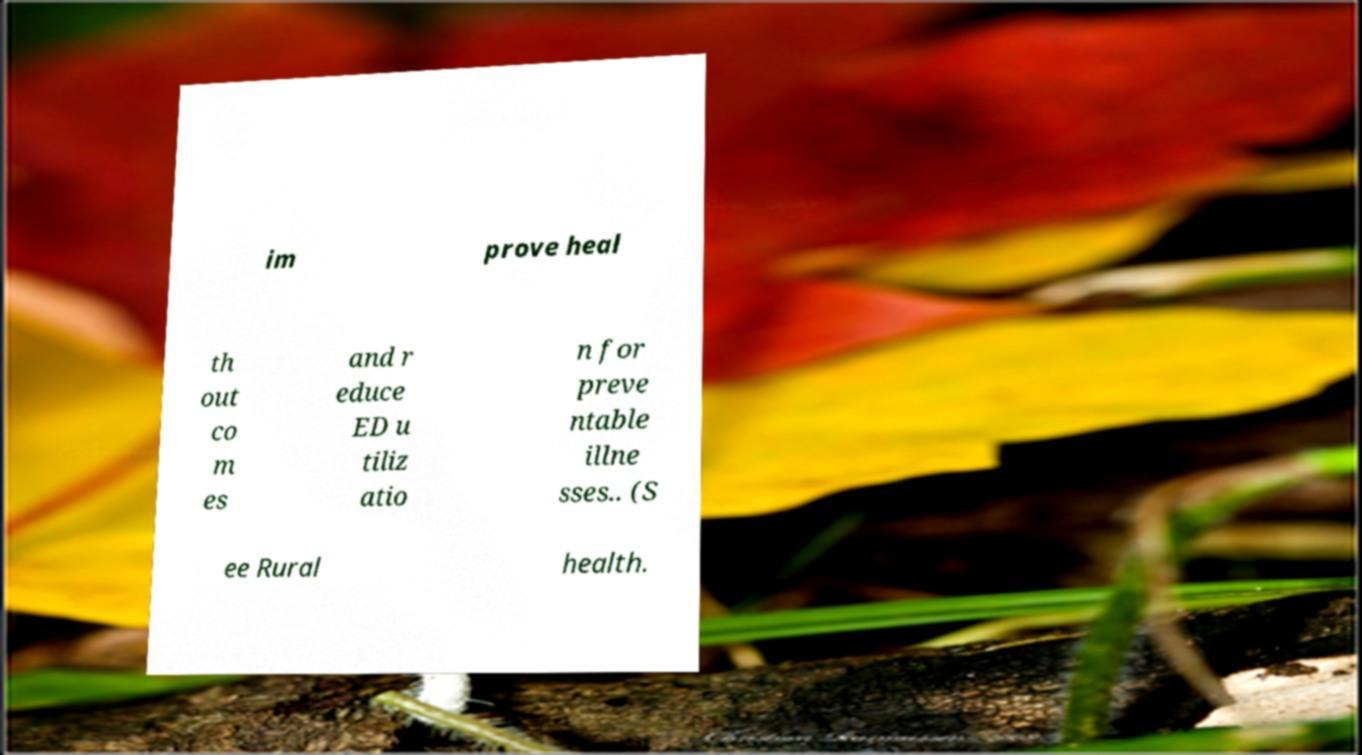I need the written content from this picture converted into text. Can you do that? im prove heal th out co m es and r educe ED u tiliz atio n for preve ntable illne sses.. (S ee Rural health. 